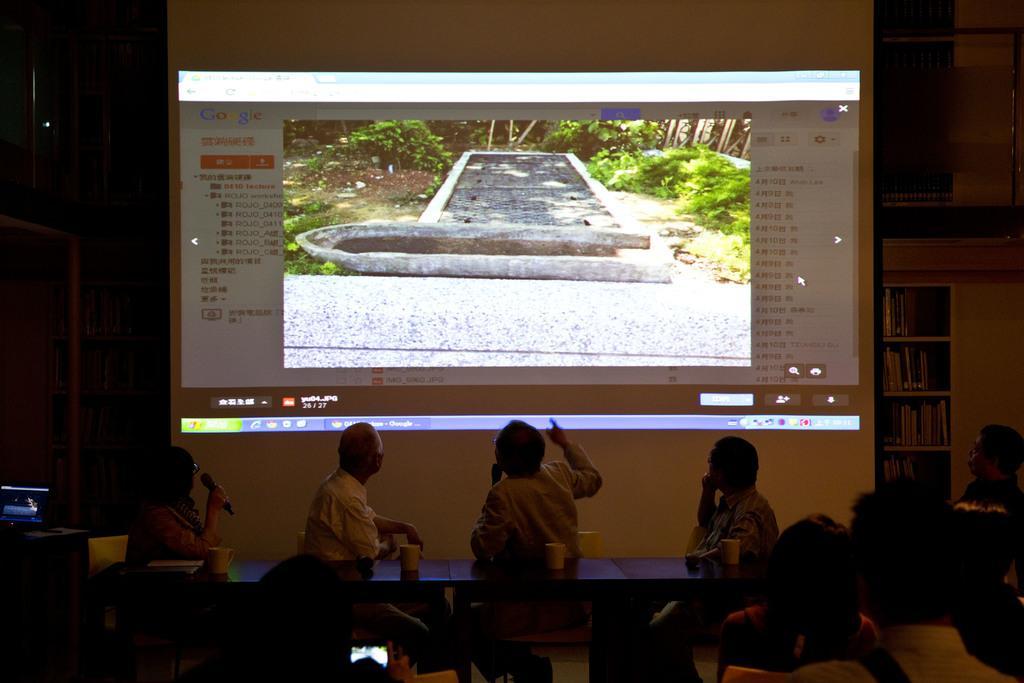Can you describe this image briefly? This image is clicked inside a room. There are tables in the middle, on that table there are glasses and there is a screen on the top. There are four people near the table who are watching that screen and there are so many people sitting in the bottom. There are books on the right side. 